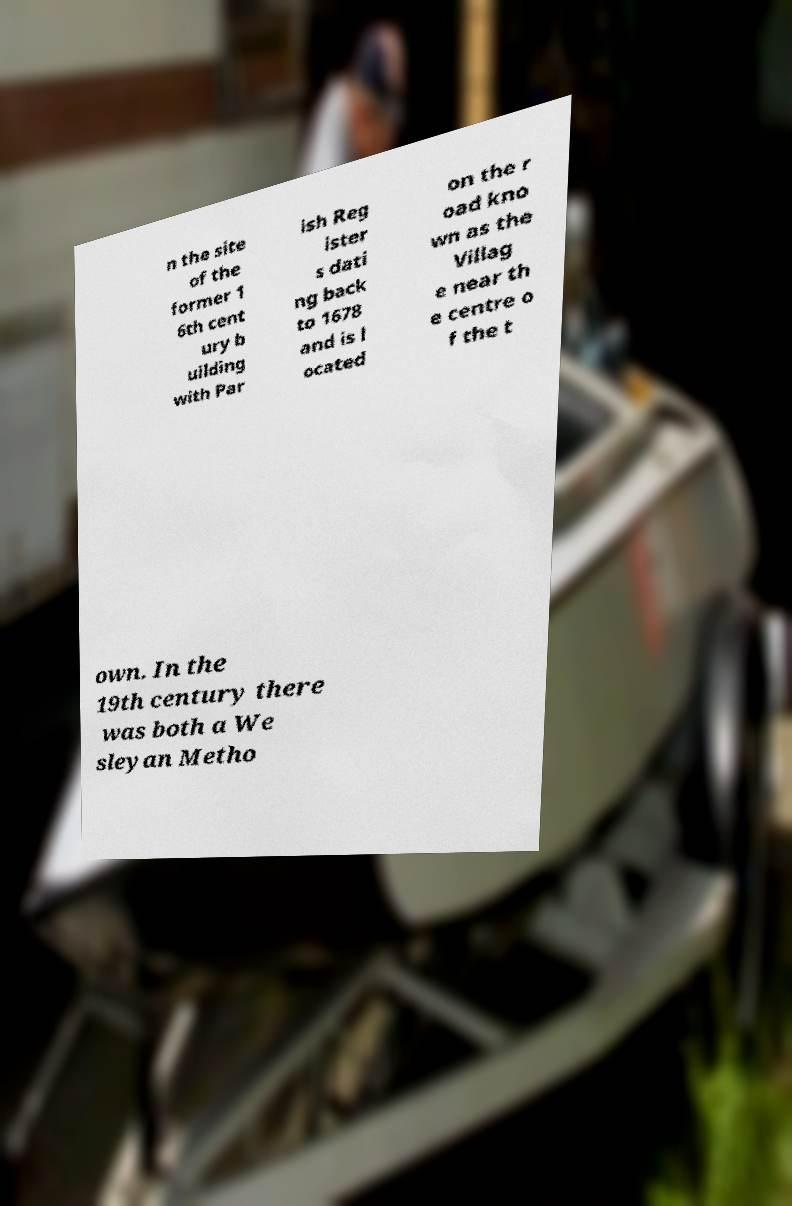I need the written content from this picture converted into text. Can you do that? n the site of the former 1 6th cent ury b uilding with Par ish Reg ister s dati ng back to 1678 and is l ocated on the r oad kno wn as the Villag e near th e centre o f the t own. In the 19th century there was both a We sleyan Metho 